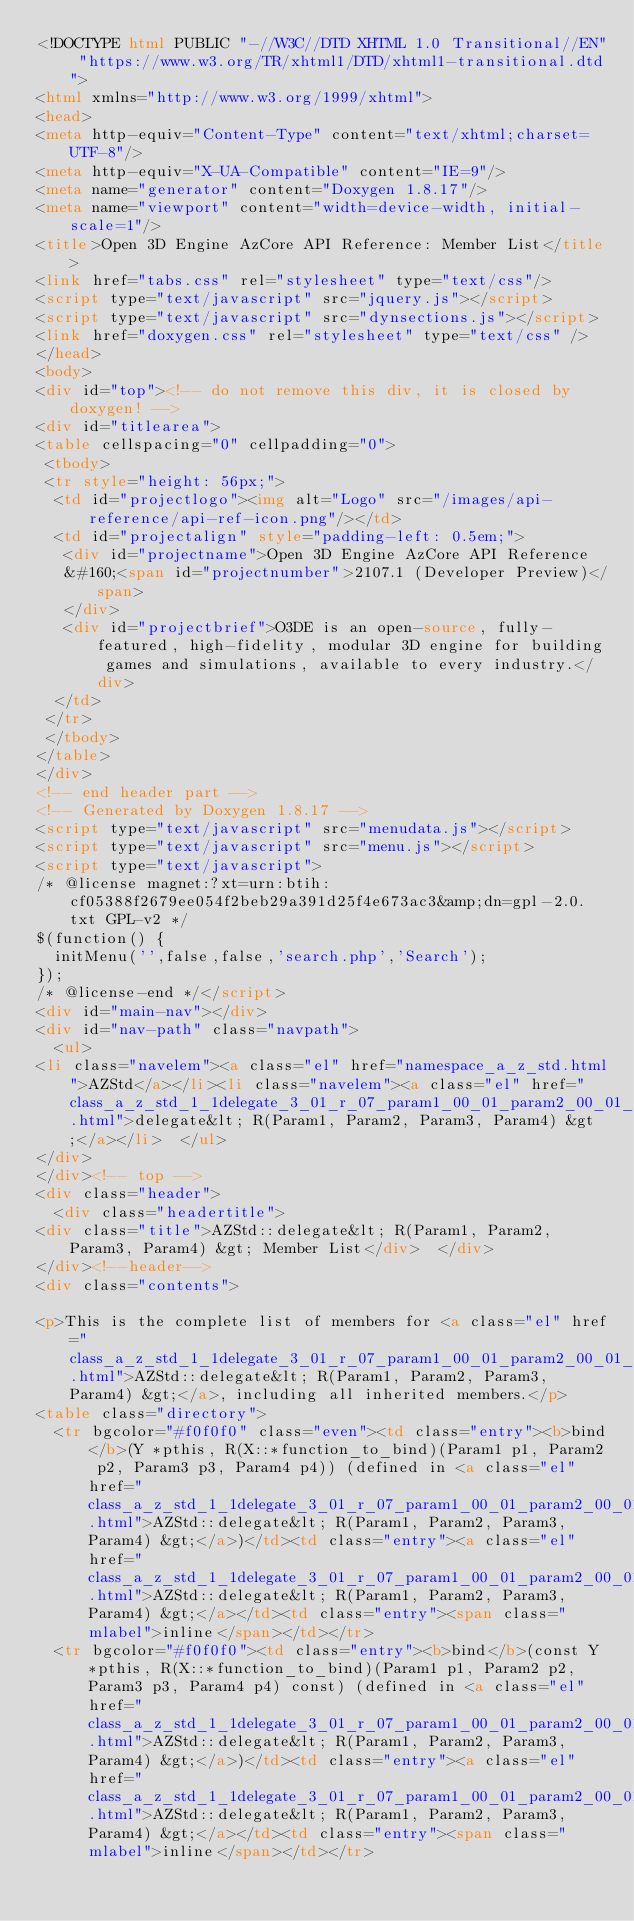Convert code to text. <code><loc_0><loc_0><loc_500><loc_500><_HTML_><!DOCTYPE html PUBLIC "-//W3C//DTD XHTML 1.0 Transitional//EN" "https://www.w3.org/TR/xhtml1/DTD/xhtml1-transitional.dtd">
<html xmlns="http://www.w3.org/1999/xhtml">
<head>
<meta http-equiv="Content-Type" content="text/xhtml;charset=UTF-8"/>
<meta http-equiv="X-UA-Compatible" content="IE=9"/>
<meta name="generator" content="Doxygen 1.8.17"/>
<meta name="viewport" content="width=device-width, initial-scale=1"/>
<title>Open 3D Engine AzCore API Reference: Member List</title>
<link href="tabs.css" rel="stylesheet" type="text/css"/>
<script type="text/javascript" src="jquery.js"></script>
<script type="text/javascript" src="dynsections.js"></script>
<link href="doxygen.css" rel="stylesheet" type="text/css" />
</head>
<body>
<div id="top"><!-- do not remove this div, it is closed by doxygen! -->
<div id="titlearea">
<table cellspacing="0" cellpadding="0">
 <tbody>
 <tr style="height: 56px;">
  <td id="projectlogo"><img alt="Logo" src="/images/api-reference/api-ref-icon.png"/></td>
  <td id="projectalign" style="padding-left: 0.5em;">
   <div id="projectname">Open 3D Engine AzCore API Reference
   &#160;<span id="projectnumber">2107.1 (Developer Preview)</span>
   </div>
   <div id="projectbrief">O3DE is an open-source, fully-featured, high-fidelity, modular 3D engine for building games and simulations, available to every industry.</div>
  </td>
 </tr>
 </tbody>
</table>
</div>
<!-- end header part -->
<!-- Generated by Doxygen 1.8.17 -->
<script type="text/javascript" src="menudata.js"></script>
<script type="text/javascript" src="menu.js"></script>
<script type="text/javascript">
/* @license magnet:?xt=urn:btih:cf05388f2679ee054f2beb29a391d25f4e673ac3&amp;dn=gpl-2.0.txt GPL-v2 */
$(function() {
  initMenu('',false,false,'search.php','Search');
});
/* @license-end */</script>
<div id="main-nav"></div>
<div id="nav-path" class="navpath">
  <ul>
<li class="navelem"><a class="el" href="namespace_a_z_std.html">AZStd</a></li><li class="navelem"><a class="el" href="class_a_z_std_1_1delegate_3_01_r_07_param1_00_01_param2_00_01_param3_00_01_param4_08_01_4.html">delegate&lt; R(Param1, Param2, Param3, Param4) &gt;</a></li>  </ul>
</div>
</div><!-- top -->
<div class="header">
  <div class="headertitle">
<div class="title">AZStd::delegate&lt; R(Param1, Param2, Param3, Param4) &gt; Member List</div>  </div>
</div><!--header-->
<div class="contents">

<p>This is the complete list of members for <a class="el" href="class_a_z_std_1_1delegate_3_01_r_07_param1_00_01_param2_00_01_param3_00_01_param4_08_01_4.html">AZStd::delegate&lt; R(Param1, Param2, Param3, Param4) &gt;</a>, including all inherited members.</p>
<table class="directory">
  <tr bgcolor="#f0f0f0" class="even"><td class="entry"><b>bind</b>(Y *pthis, R(X::*function_to_bind)(Param1 p1, Param2 p2, Param3 p3, Param4 p4)) (defined in <a class="el" href="class_a_z_std_1_1delegate_3_01_r_07_param1_00_01_param2_00_01_param3_00_01_param4_08_01_4.html">AZStd::delegate&lt; R(Param1, Param2, Param3, Param4) &gt;</a>)</td><td class="entry"><a class="el" href="class_a_z_std_1_1delegate_3_01_r_07_param1_00_01_param2_00_01_param3_00_01_param4_08_01_4.html">AZStd::delegate&lt; R(Param1, Param2, Param3, Param4) &gt;</a></td><td class="entry"><span class="mlabel">inline</span></td></tr>
  <tr bgcolor="#f0f0f0"><td class="entry"><b>bind</b>(const Y *pthis, R(X::*function_to_bind)(Param1 p1, Param2 p2, Param3 p3, Param4 p4) const) (defined in <a class="el" href="class_a_z_std_1_1delegate_3_01_r_07_param1_00_01_param2_00_01_param3_00_01_param4_08_01_4.html">AZStd::delegate&lt; R(Param1, Param2, Param3, Param4) &gt;</a>)</td><td class="entry"><a class="el" href="class_a_z_std_1_1delegate_3_01_r_07_param1_00_01_param2_00_01_param3_00_01_param4_08_01_4.html">AZStd::delegate&lt; R(Param1, Param2, Param3, Param4) &gt;</a></td><td class="entry"><span class="mlabel">inline</span></td></tr></code> 